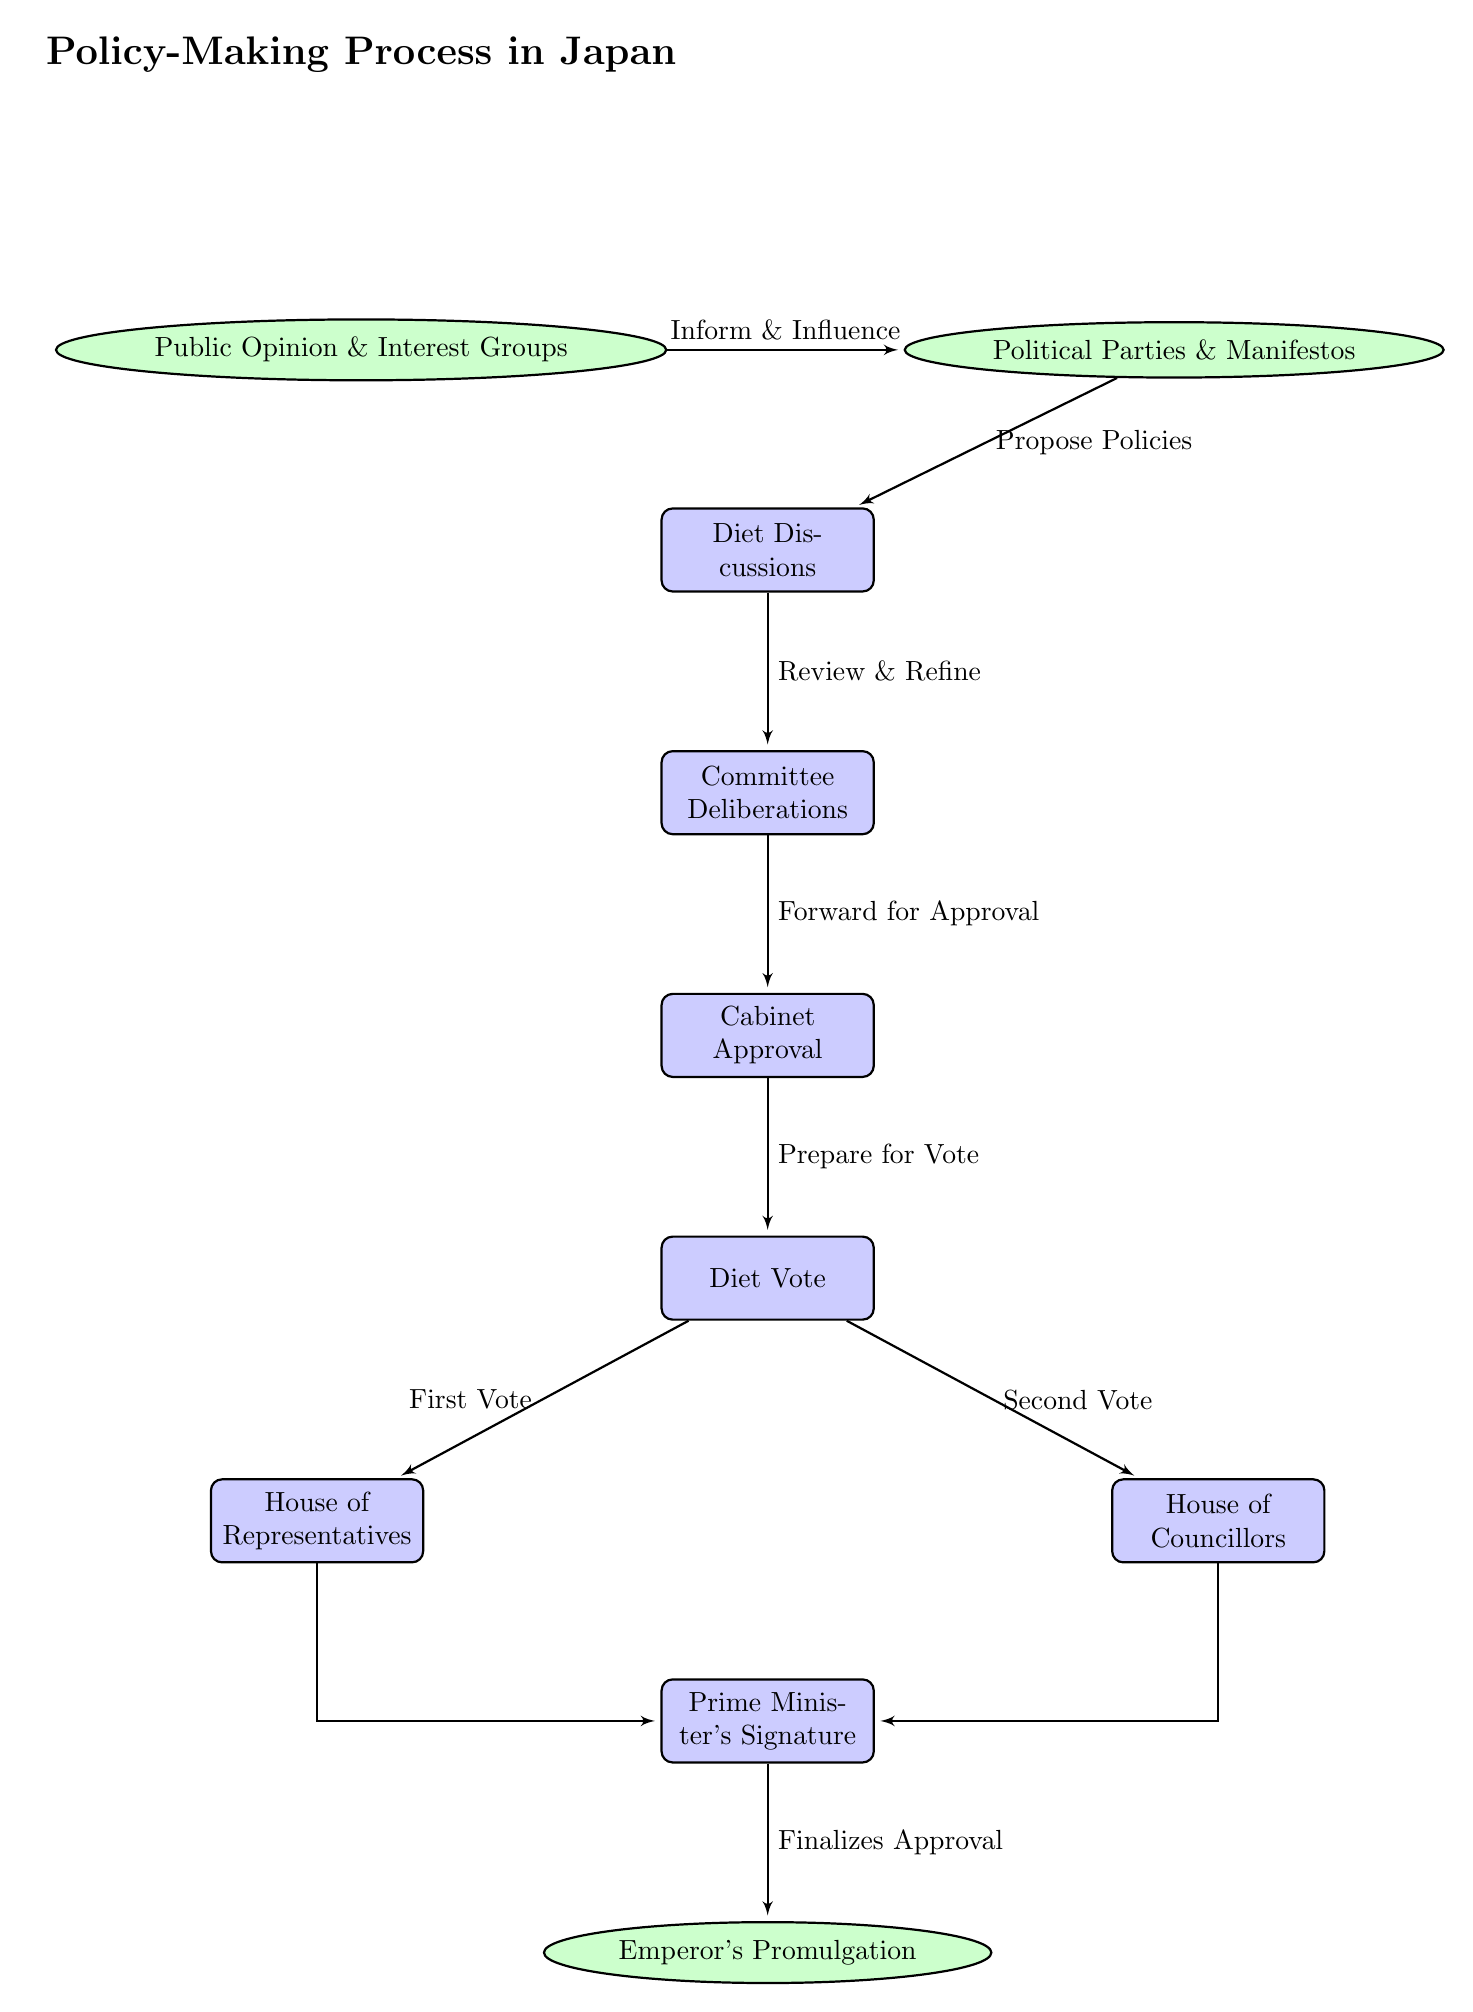What nodes are present in the diagram? The diagram includes 10 distinct nodes which are: Public Opinion & Interest Groups, Political Parties & Manifestos, Diet Discussions, Committee Deliberations, Cabinet Approval, Diet Vote, House of Representatives, House of Councillors, Prime Minister's Signature, and Emperor's Promulgation.
Answer: 10 What is the first node in the flowchart? The first node in the flowchart represents the initial stage of the policy-making process, which is Public Opinion & Interest Groups. This node is located at the top and initiates the flow of the process.
Answer: Public Opinion & Interest Groups How many arrows are present in the diagram? The diagram contains 9 arrows that illustrate the flow from one stage of the policy-making process to another, indicating the connections between nodes.
Answer: 9 What action follows Diet Discussions? After Diet Discussions, the next action in the process is Committee Deliberations. This step comes immediately under Diet Discussions in the flowchart.
Answer: Committee Deliberations Which two nodes lead to the Prime Minister's Signature? The nodes that lead to the Prime Minister's Signature are the House of Representatives and the House of Councillors. Both nodes connect to the Prime Minister's Signature before the final step in the policy-making process.
Answer: House of Representatives, House of Councillors What label is associated with the arrow from Cabinet Approval to Diet Vote? The arrow connecting Cabinet Approval to Diet Vote is labeled "Prepare for Vote." This indicates the action taken after cabinet approval and before the vote by the diet.
Answer: Prepare for Vote What is the final step in the policy-making process? The final step in the policy-making process is the Emperor's Promulgation. This step represents the last stage after all necessary approvals have been completed.
Answer: Emperor's Promulgation Describe the relationship between Public Opinion & Interest Groups and Political Parties & Manifestos. The relationship between these two nodes is described by the arrow that connects them, labeled "Inform & Influence." This shows how public opinions and interest groups shape political parties' policy proposals.
Answer: Inform & Influence What stage occurs directly after Committee Deliberations? The stage that occurs directly after Committee Deliberations is Cabinet Approval. This means that once discussions in the committee are complete, the committee forwards the proposals for cabinet approval.
Answer: Cabinet Approval 